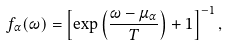<formula> <loc_0><loc_0><loc_500><loc_500>f _ { \alpha } ( \omega ) = \left [ \exp \left ( \frac { \omega - \mu _ { \alpha } } { T } \right ) + 1 \right ] ^ { - 1 } ,</formula> 